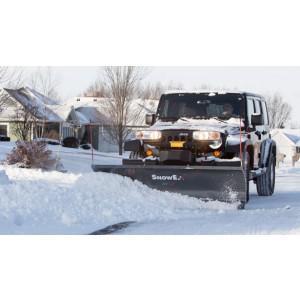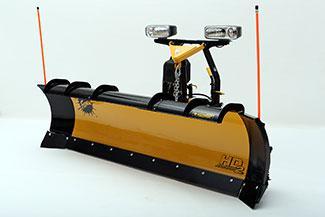The first image is the image on the left, the second image is the image on the right. Assess this claim about the two images: "Left image shows a camera-facing vehicle plowing a snow-covered ground.". Correct or not? Answer yes or no. Yes. The first image is the image on the left, the second image is the image on the right. Examine the images to the left and right. Is the description "A pile of snow is being bulldozed by a vehicle." accurate? Answer yes or no. Yes. 